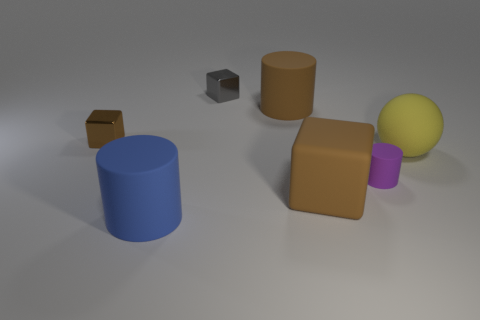What color is the large matte cylinder on the right side of the blue object?
Give a very brief answer. Brown. There is a large matte cylinder that is in front of the rubber cylinder that is on the right side of the large cube; what color is it?
Keep it short and to the point. Blue. The cube that is the same size as the brown metal object is what color?
Give a very brief answer. Gray. What number of shiny cubes are to the left of the big blue rubber thing and behind the big brown rubber cylinder?
Keep it short and to the point. 0. There is a small shiny thing that is the same color as the matte cube; what shape is it?
Ensure brevity in your answer.  Cube. There is a cylinder that is on the left side of the tiny cylinder and in front of the brown shiny thing; what material is it?
Your response must be concise. Rubber. Is the number of purple cylinders that are to the right of the large ball less than the number of small gray metallic cubes on the left side of the tiny purple matte object?
Give a very brief answer. Yes. There is a gray object that is the same material as the small brown cube; what size is it?
Your answer should be very brief. Small. Is there anything else of the same color as the big sphere?
Make the answer very short. No. Is the material of the tiny brown thing the same as the tiny block behind the brown cylinder?
Make the answer very short. Yes. 